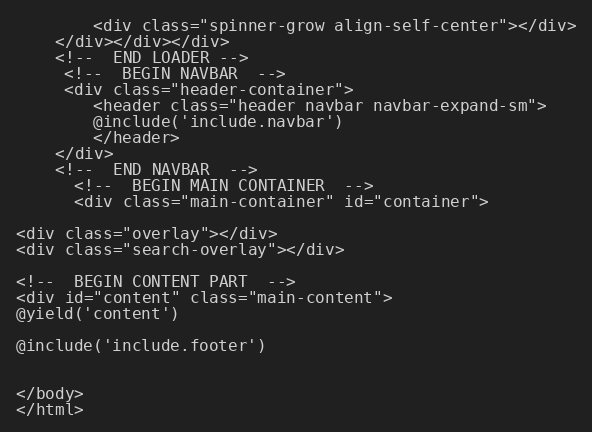<code> <loc_0><loc_0><loc_500><loc_500><_PHP_>        <div class="spinner-grow align-self-center"></div>
    </div></div></div>
    <!--  END LOADER -->
     <!--  BEGIN NAVBAR  -->
     <div class="header-container">
        <header class="header navbar navbar-expand-sm"> 
        @include('include.navbar')
        </header>
    </div>
    <!--  END NAVBAR  -->
      <!--  BEGIN MAIN CONTAINER  -->
      <div class="main-container" id="container">

<div class="overlay"></div>
<div class="search-overlay"></div>

<!--  BEGIN CONTENT PART  -->
<div id="content" class="main-content">
@yield('content')

@include('include.footer')


</body>
</html></code> 